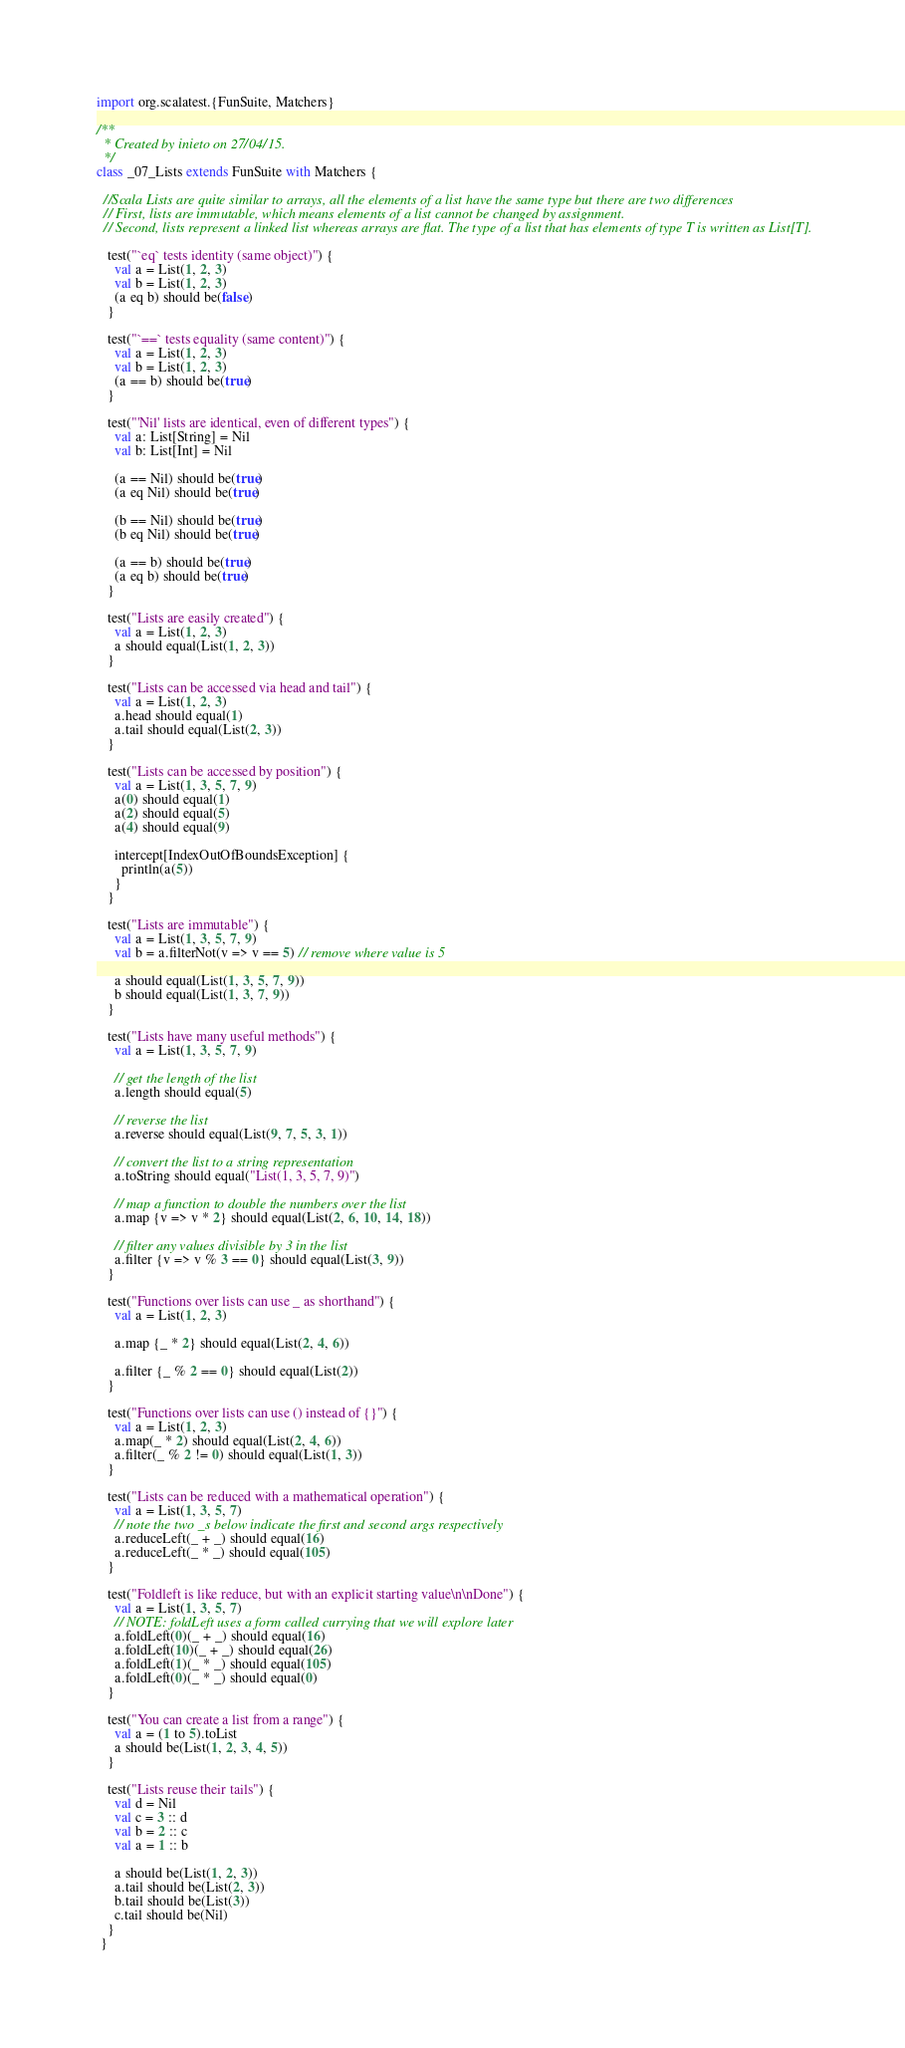<code> <loc_0><loc_0><loc_500><loc_500><_Scala_>import org.scalatest.{FunSuite, Matchers}

/**
  * Created by inieto on 27/04/15.
  */
class _07_Lists extends FunSuite with Matchers {

  //Scala Lists are quite similar to arrays, all the elements of a list have the same type but there are two differences
  // First, lists are immutable, which means elements of a list cannot be changed by assignment.
  // Second, lists represent a linked list whereas arrays are flat. The type of a list that has elements of type T is written as List[T].

   test("`eq` tests identity (same object)") {
     val a = List(1, 2, 3)
     val b = List(1, 2, 3)
     (a eq b) should be(false)
   }

   test("`==` tests equality (same content)") {
     val a = List(1, 2, 3)
     val b = List(1, 2, 3)
     (a == b) should be(true)
   }

   test("'Nil' lists are identical, even of different types") {
     val a: List[String] = Nil
     val b: List[Int] = Nil

     (a == Nil) should be(true)
     (a eq Nil) should be(true)

     (b == Nil) should be(true)
     (b eq Nil) should be(true)

     (a == b) should be(true)
     (a eq b) should be(true)
   }

   test("Lists are easily created") {
     val a = List(1, 2, 3)
     a should equal(List(1, 2, 3))
   }

   test("Lists can be accessed via head and tail") {
     val a = List(1, 2, 3)
     a.head should equal(1)
     a.tail should equal(List(2, 3))
   }

   test("Lists can be accessed by position") {
     val a = List(1, 3, 5, 7, 9)
     a(0) should equal(1)
     a(2) should equal(5)
     a(4) should equal(9)

     intercept[IndexOutOfBoundsException] {
       println(a(5))
     }
   }

   test("Lists are immutable") {
     val a = List(1, 3, 5, 7, 9)
     val b = a.filterNot(v => v == 5) // remove where value is 5

     a should equal(List(1, 3, 5, 7, 9))
     b should equal(List(1, 3, 7, 9))
   }

   test("Lists have many useful methods") {
     val a = List(1, 3, 5, 7, 9)

     // get the length of the list
     a.length should equal(5)

     // reverse the list
     a.reverse should equal(List(9, 7, 5, 3, 1))

     // convert the list to a string representation
     a.toString should equal("List(1, 3, 5, 7, 9)")

     // map a function to double the numbers over the list
     a.map {v => v * 2} should equal(List(2, 6, 10, 14, 18))

     // filter any values divisible by 3 in the list
     a.filter {v => v % 3 == 0} should equal(List(3, 9))
   }

   test("Functions over lists can use _ as shorthand") {
     val a = List(1, 2, 3)

     a.map {_ * 2} should equal(List(2, 4, 6))

     a.filter {_ % 2 == 0} should equal(List(2))
   }

   test("Functions over lists can use () instead of {}") {
     val a = List(1, 2, 3)
     a.map(_ * 2) should equal(List(2, 4, 6))
     a.filter(_ % 2 != 0) should equal(List(1, 3))
   }

   test("Lists can be reduced with a mathematical operation") {
     val a = List(1, 3, 5, 7)
     // note the two _s below indicate the first and second args respectively
     a.reduceLeft(_ + _) should equal(16)
     a.reduceLeft(_ * _) should equal(105)
   }

   test("Foldleft is like reduce, but with an explicit starting value\n\nDone") {
     val a = List(1, 3, 5, 7)
     // NOTE: foldLeft uses a form called currying that we will explore later
     a.foldLeft(0)(_ + _) should equal(16)
     a.foldLeft(10)(_ + _) should equal(26)
     a.foldLeft(1)(_ * _) should equal(105)
     a.foldLeft(0)(_ * _) should equal(0)
   }

   test("You can create a list from a range") {
     val a = (1 to 5).toList
     a should be(List(1, 2, 3, 4, 5))
   }

   test("Lists reuse their tails") {
     val d = Nil
     val c = 3 :: d
     val b = 2 :: c
     val a = 1 :: b

     a should be(List(1, 2, 3))
     a.tail should be(List(2, 3))
     b.tail should be(List(3))
     c.tail should be(Nil)
   }
 }
</code> 